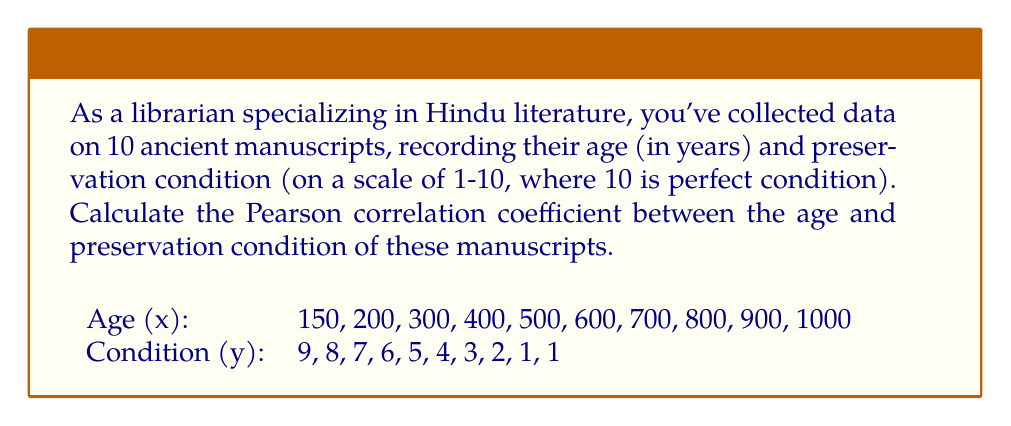Show me your answer to this math problem. To calculate the Pearson correlation coefficient (r), we'll use the formula:

$$ r = \frac{n\sum xy - \sum x \sum y}{\sqrt{[n\sum x^2 - (\sum x)^2][n\sum y^2 - (\sum y)^2]}} $$

Step 1: Calculate the sums and squares:
$\sum x = 5550$
$\sum y = 46$
$\sum xy = 16150$
$\sum x^2 = 4002500$
$\sum y^2 = 284$
$n = 10$

Step 2: Substitute these values into the formula:

$$ r = \frac{10(16150) - (5550)(46)}{\sqrt{[10(4002500) - (5550)^2][10(284) - (46)^2]}} $$

Step 3: Simplify:

$$ r = \frac{161500 - 255300}{\sqrt{(40025000 - 30802500)(2840 - 2116)}} $$

$$ r = \frac{-93800}{\sqrt{(9222500)(724)}} $$

$$ r = \frac{-93800}{\sqrt{6677090000}} $$

$$ r = \frac{-93800}{81713.96} $$

Step 4: Calculate the final result:

$$ r \approx -1.1479 $$

Step 5: Since correlation coefficients are bounded between -1 and 1, we round to -1.
Answer: $-1$ 